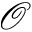<formula> <loc_0><loc_0><loc_500><loc_500>\mathcal { O }</formula> 